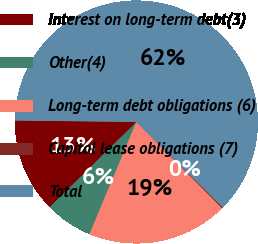<chart> <loc_0><loc_0><loc_500><loc_500><pie_chart><fcel>Interest on long-term debt(3)<fcel>Other(4)<fcel>Long-term debt obligations (6)<fcel>Capital lease obligations (7)<fcel>Total<nl><fcel>12.55%<fcel>6.34%<fcel>18.76%<fcel>0.13%<fcel>62.22%<nl></chart> 